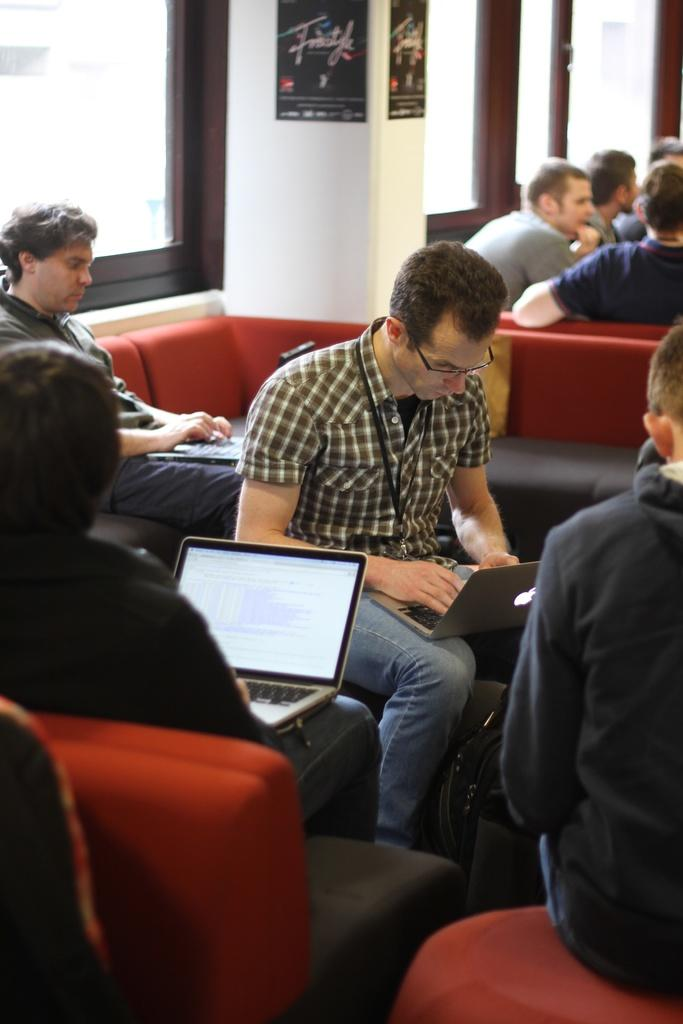What are the people in the foreground of the image doing? The people in the foreground of the image are sitting on couches. What objects are the people holding? The people are holding laptops. What type of windows can be seen in the image? There are glass windows visible at the top of the image. Where are other people located in the image? There are people sitting near the glass windows. Can you tell me how many pens are visible on the table in the image? There is no mention of pens in the provided facts, so it cannot be determined if any are visible in the image. 